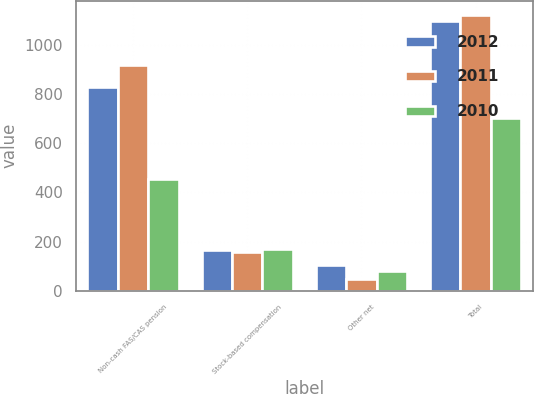<chart> <loc_0><loc_0><loc_500><loc_500><stacked_bar_chart><ecel><fcel>Non-cash FAS/CAS pension<fcel>Stock-based compensation<fcel>Other net<fcel>Total<nl><fcel>2012<fcel>830<fcel>167<fcel>104<fcel>1101<nl><fcel>2011<fcel>922<fcel>157<fcel>46<fcel>1125<nl><fcel>2010<fcel>454<fcel>168<fcel>81<fcel>703<nl></chart> 